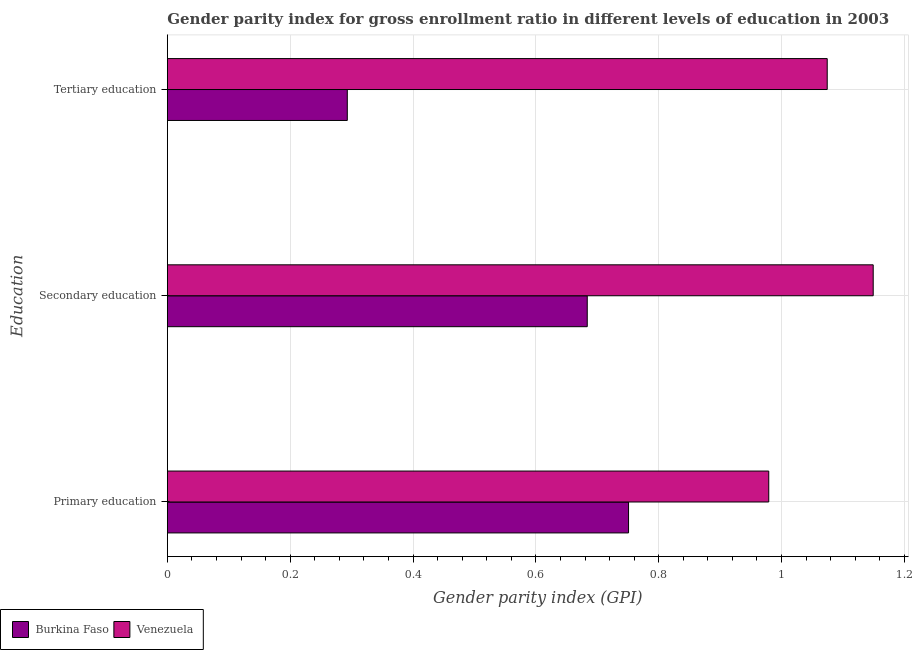How many groups of bars are there?
Offer a terse response. 3. How many bars are there on the 1st tick from the bottom?
Your response must be concise. 2. What is the label of the 2nd group of bars from the top?
Your answer should be very brief. Secondary education. What is the gender parity index in tertiary education in Burkina Faso?
Ensure brevity in your answer.  0.29. Across all countries, what is the maximum gender parity index in primary education?
Your answer should be very brief. 0.98. Across all countries, what is the minimum gender parity index in primary education?
Make the answer very short. 0.75. In which country was the gender parity index in secondary education maximum?
Offer a very short reply. Venezuela. In which country was the gender parity index in primary education minimum?
Offer a terse response. Burkina Faso. What is the total gender parity index in secondary education in the graph?
Offer a very short reply. 1.83. What is the difference between the gender parity index in tertiary education in Burkina Faso and that in Venezuela?
Keep it short and to the point. -0.78. What is the difference between the gender parity index in tertiary education in Burkina Faso and the gender parity index in primary education in Venezuela?
Ensure brevity in your answer.  -0.69. What is the average gender parity index in primary education per country?
Your answer should be very brief. 0.87. What is the difference between the gender parity index in secondary education and gender parity index in primary education in Burkina Faso?
Provide a short and direct response. -0.07. In how many countries, is the gender parity index in secondary education greater than 0.2 ?
Keep it short and to the point. 2. What is the ratio of the gender parity index in secondary education in Venezuela to that in Burkina Faso?
Offer a terse response. 1.68. Is the difference between the gender parity index in secondary education in Venezuela and Burkina Faso greater than the difference between the gender parity index in tertiary education in Venezuela and Burkina Faso?
Your answer should be very brief. No. What is the difference between the highest and the second highest gender parity index in secondary education?
Offer a very short reply. 0.47. What is the difference between the highest and the lowest gender parity index in secondary education?
Your answer should be compact. 0.47. In how many countries, is the gender parity index in primary education greater than the average gender parity index in primary education taken over all countries?
Make the answer very short. 1. Is the sum of the gender parity index in tertiary education in Venezuela and Burkina Faso greater than the maximum gender parity index in primary education across all countries?
Your answer should be compact. Yes. What does the 1st bar from the top in Tertiary education represents?
Offer a terse response. Venezuela. What does the 1st bar from the bottom in Tertiary education represents?
Ensure brevity in your answer.  Burkina Faso. Is it the case that in every country, the sum of the gender parity index in primary education and gender parity index in secondary education is greater than the gender parity index in tertiary education?
Your response must be concise. Yes. Are the values on the major ticks of X-axis written in scientific E-notation?
Make the answer very short. No. How many legend labels are there?
Offer a very short reply. 2. How are the legend labels stacked?
Make the answer very short. Horizontal. What is the title of the graph?
Offer a very short reply. Gender parity index for gross enrollment ratio in different levels of education in 2003. Does "Equatorial Guinea" appear as one of the legend labels in the graph?
Offer a very short reply. No. What is the label or title of the X-axis?
Offer a terse response. Gender parity index (GPI). What is the label or title of the Y-axis?
Ensure brevity in your answer.  Education. What is the Gender parity index (GPI) of Burkina Faso in Primary education?
Your answer should be very brief. 0.75. What is the Gender parity index (GPI) of Venezuela in Primary education?
Your response must be concise. 0.98. What is the Gender parity index (GPI) in Burkina Faso in Secondary education?
Provide a short and direct response. 0.68. What is the Gender parity index (GPI) of Venezuela in Secondary education?
Your answer should be compact. 1.15. What is the Gender parity index (GPI) in Burkina Faso in Tertiary education?
Offer a terse response. 0.29. What is the Gender parity index (GPI) of Venezuela in Tertiary education?
Your response must be concise. 1.07. Across all Education, what is the maximum Gender parity index (GPI) in Burkina Faso?
Your answer should be very brief. 0.75. Across all Education, what is the maximum Gender parity index (GPI) in Venezuela?
Offer a very short reply. 1.15. Across all Education, what is the minimum Gender parity index (GPI) of Burkina Faso?
Provide a succinct answer. 0.29. Across all Education, what is the minimum Gender parity index (GPI) in Venezuela?
Your response must be concise. 0.98. What is the total Gender parity index (GPI) of Burkina Faso in the graph?
Provide a succinct answer. 1.73. What is the total Gender parity index (GPI) in Venezuela in the graph?
Keep it short and to the point. 3.2. What is the difference between the Gender parity index (GPI) of Burkina Faso in Primary education and that in Secondary education?
Your answer should be compact. 0.07. What is the difference between the Gender parity index (GPI) of Venezuela in Primary education and that in Secondary education?
Make the answer very short. -0.17. What is the difference between the Gender parity index (GPI) in Burkina Faso in Primary education and that in Tertiary education?
Offer a very short reply. 0.46. What is the difference between the Gender parity index (GPI) of Venezuela in Primary education and that in Tertiary education?
Your answer should be very brief. -0.1. What is the difference between the Gender parity index (GPI) of Burkina Faso in Secondary education and that in Tertiary education?
Provide a succinct answer. 0.39. What is the difference between the Gender parity index (GPI) of Venezuela in Secondary education and that in Tertiary education?
Keep it short and to the point. 0.07. What is the difference between the Gender parity index (GPI) of Burkina Faso in Primary education and the Gender parity index (GPI) of Venezuela in Secondary education?
Provide a short and direct response. -0.4. What is the difference between the Gender parity index (GPI) in Burkina Faso in Primary education and the Gender parity index (GPI) in Venezuela in Tertiary education?
Make the answer very short. -0.32. What is the difference between the Gender parity index (GPI) in Burkina Faso in Secondary education and the Gender parity index (GPI) in Venezuela in Tertiary education?
Provide a short and direct response. -0.39. What is the average Gender parity index (GPI) of Burkina Faso per Education?
Offer a terse response. 0.58. What is the average Gender parity index (GPI) of Venezuela per Education?
Offer a terse response. 1.07. What is the difference between the Gender parity index (GPI) in Burkina Faso and Gender parity index (GPI) in Venezuela in Primary education?
Provide a short and direct response. -0.23. What is the difference between the Gender parity index (GPI) in Burkina Faso and Gender parity index (GPI) in Venezuela in Secondary education?
Ensure brevity in your answer.  -0.47. What is the difference between the Gender parity index (GPI) in Burkina Faso and Gender parity index (GPI) in Venezuela in Tertiary education?
Provide a short and direct response. -0.78. What is the ratio of the Gender parity index (GPI) in Burkina Faso in Primary education to that in Secondary education?
Offer a very short reply. 1.1. What is the ratio of the Gender parity index (GPI) in Venezuela in Primary education to that in Secondary education?
Ensure brevity in your answer.  0.85. What is the ratio of the Gender parity index (GPI) in Burkina Faso in Primary education to that in Tertiary education?
Your answer should be very brief. 2.56. What is the ratio of the Gender parity index (GPI) of Venezuela in Primary education to that in Tertiary education?
Provide a succinct answer. 0.91. What is the ratio of the Gender parity index (GPI) in Burkina Faso in Secondary education to that in Tertiary education?
Make the answer very short. 2.33. What is the ratio of the Gender parity index (GPI) in Venezuela in Secondary education to that in Tertiary education?
Ensure brevity in your answer.  1.07. What is the difference between the highest and the second highest Gender parity index (GPI) of Burkina Faso?
Provide a short and direct response. 0.07. What is the difference between the highest and the second highest Gender parity index (GPI) in Venezuela?
Your response must be concise. 0.07. What is the difference between the highest and the lowest Gender parity index (GPI) in Burkina Faso?
Provide a succinct answer. 0.46. What is the difference between the highest and the lowest Gender parity index (GPI) of Venezuela?
Provide a succinct answer. 0.17. 